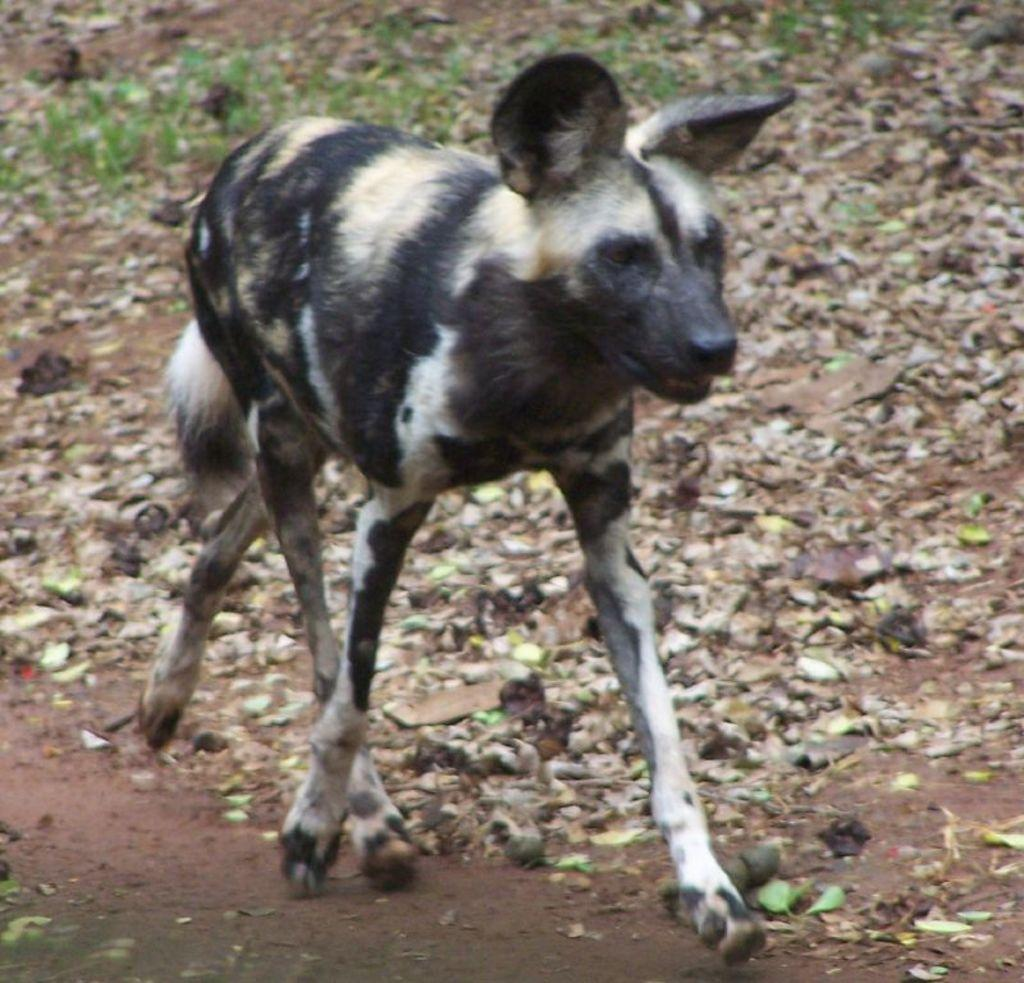What type of living creature is in the image? There is an animal in the image. What can be seen on the ground in the image? There are leaves on the ground in the image. How many rabbits are using the transport in the image? There are no rabbits or transport present in the image. What mathematical operation can be performed with the leaves in the image? The leaves in the image are not related to mathematical operations, such as addition. 